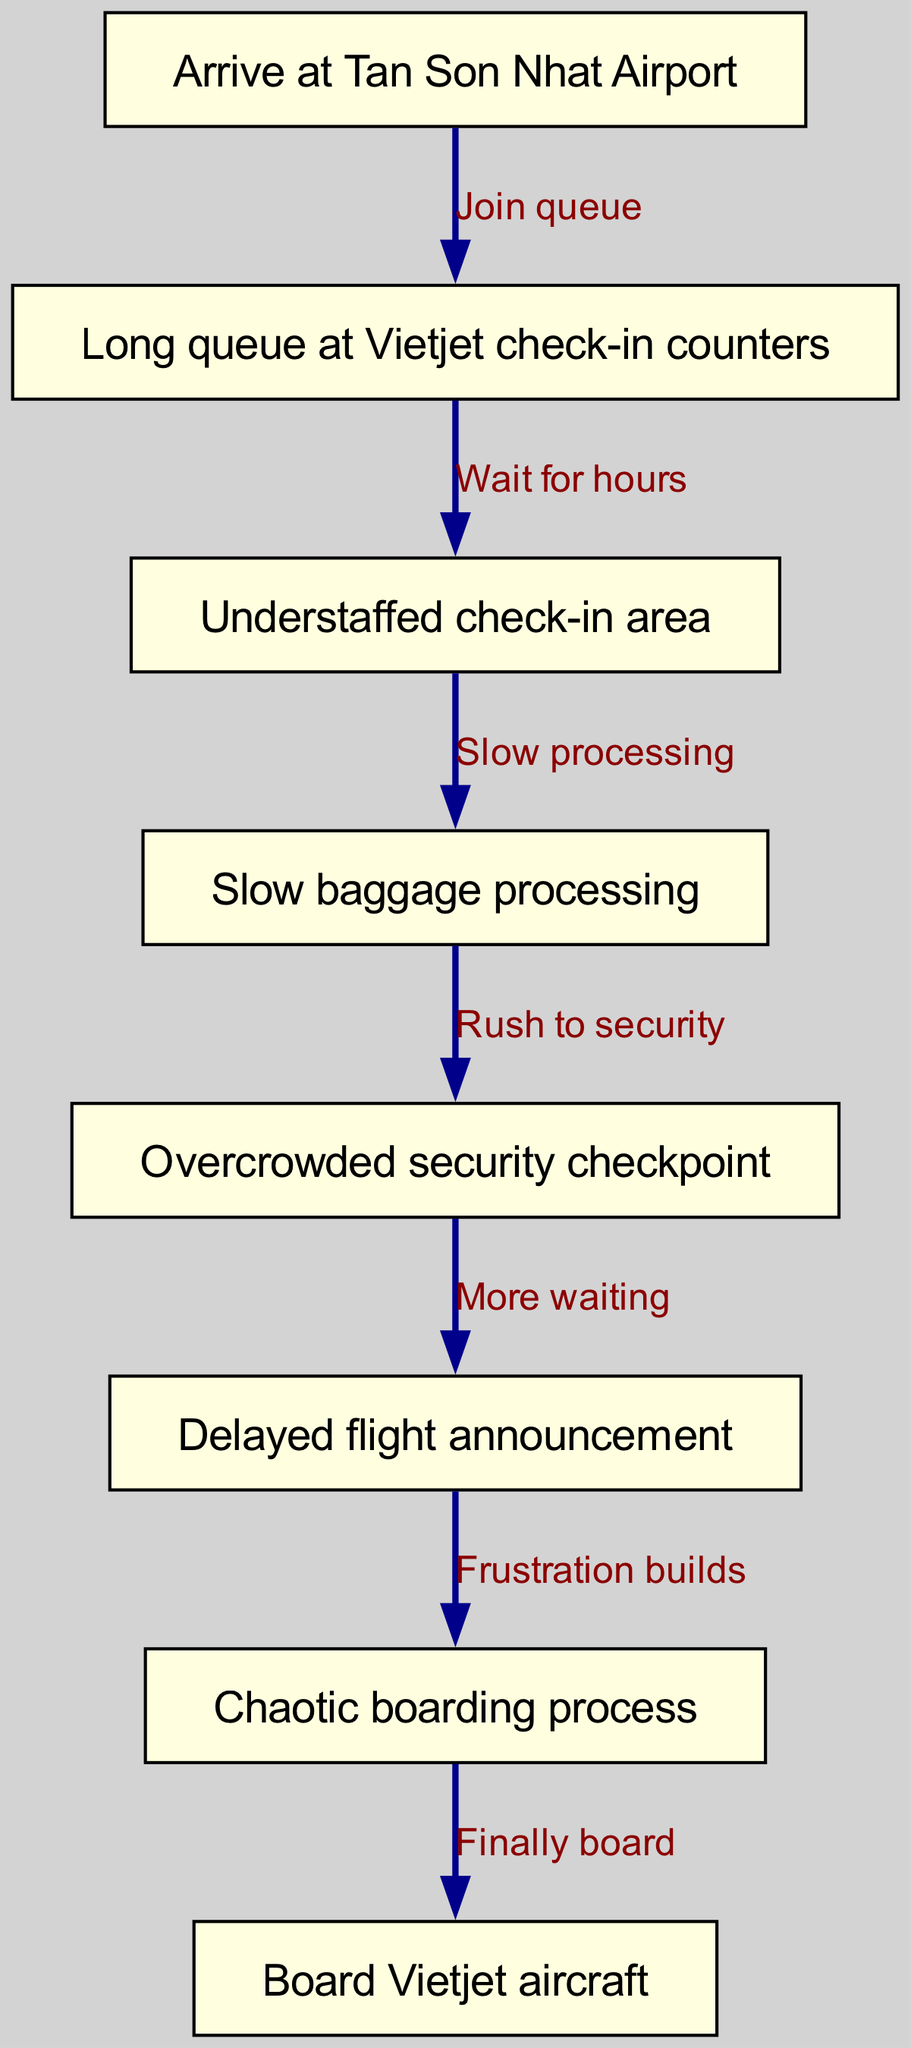What is the first step upon arriving at the airport? The first node in the diagram indicates that the initial step is to arrive at Tan Son Nhat Airport.
Answer: Arrive at Tan Son Nhat Airport What label describes the problem at the check-in counters? The second node specifically mentions "Long queue at Vietjet check-in counters" as the issue faced by passengers.
Answer: Long queue at Vietjet check-in counters How many nodes are present in the diagram? By counting the nodes listed in the data, there are a total of 8 distinct nodes that illustrate the airport procedures.
Answer: 8 What happens after the check-in wait? From the diagram, after waiting at the check-in counters, the next step is dealing with an "Understaffed check-in area." This is indicated by the directed edge connecting the check-in queue to this node.
Answer: Understaffed check-in area What does the journey from security to boarding involve? After the overcrowded security checkpoint, the diagram shows a delay through "Delayed flight announcement" followed by "Chaotic boarding process," illustrating a build-up of frustrations. This requires tracking from the security node through to boarding.
Answer: Frustration builds Which process comes before boarding the Vietjet aircraft? The diagram specifies the "Chaotic boarding process" as the direct precursor to boarding the aircraft, pinpointing it as the necessary step immediately before.
Answer: Chaotic boarding process What is the impact of slow baggage processing on the overall flow? The slow baggage processing identified as a node indicates that it compounds the overall delay in reaching the security checkpoint, which subsequently leads to frustrations illustrated in the later steps.
Answer: Slow baggage processing What relationship exists between delayed flight announcements and the boarding process? The edge from "Delayed flight announcement" to "Chaotic boarding process" indicates that delays contribute to a chaotic atmosphere when boarding, reflecting heightened passenger frustrations.
Answer: Frustration builds 